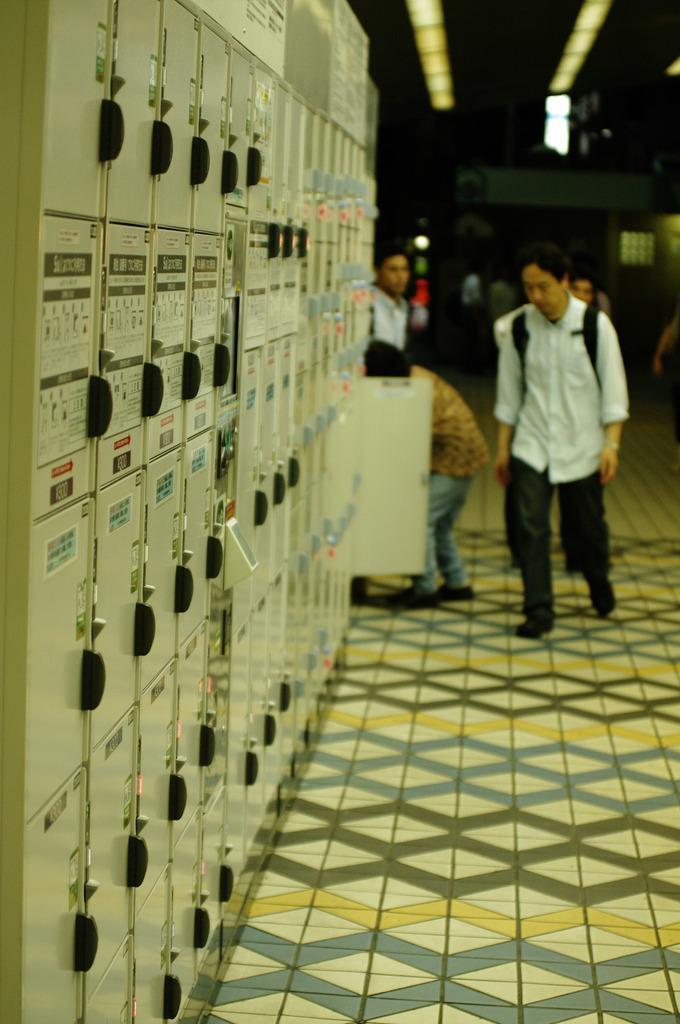Can you describe this image briefly? In this image, we can see persons wearing clothes. There is a panel board on the left side of the image. There are lights in the top right of the image. 